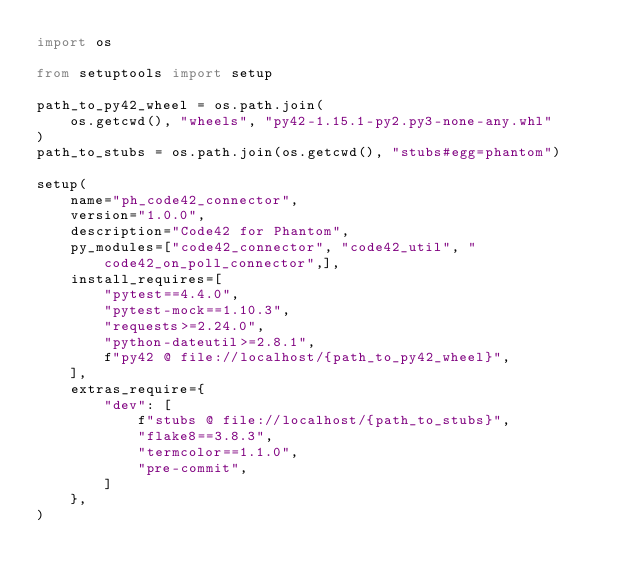<code> <loc_0><loc_0><loc_500><loc_500><_Python_>import os

from setuptools import setup

path_to_py42_wheel = os.path.join(
    os.getcwd(), "wheels", "py42-1.15.1-py2.py3-none-any.whl"
)
path_to_stubs = os.path.join(os.getcwd(), "stubs#egg=phantom")

setup(
    name="ph_code42_connector",
    version="1.0.0",
    description="Code42 for Phantom",
    py_modules=["code42_connector", "code42_util", "code42_on_poll_connector",],
    install_requires=[
        "pytest==4.4.0",
        "pytest-mock==1.10.3",
        "requests>=2.24.0",
        "python-dateutil>=2.8.1",
        f"py42 @ file://localhost/{path_to_py42_wheel}",
    ],
    extras_require={
        "dev": [
            f"stubs @ file://localhost/{path_to_stubs}",
            "flake8==3.8.3",
            "termcolor==1.1.0",
            "pre-commit",
        ]
    },
)
</code> 